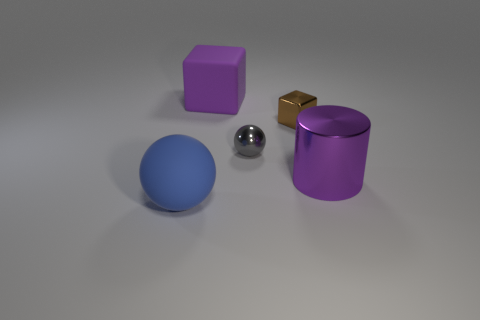What is the material of the purple thing in front of the large rubber object behind the tiny gray shiny thing?
Your answer should be very brief. Metal. Is there another thing of the same shape as the blue thing?
Keep it short and to the point. Yes. What color is the metallic thing that is the same size as the purple block?
Your answer should be very brief. Purple. How many objects are either things to the left of the big purple metal thing or objects that are to the left of the big matte cube?
Provide a succinct answer. 4. How many objects are either small gray metal things or large rubber things?
Offer a very short reply. 3. There is a thing that is both to the right of the big purple rubber object and on the left side of the brown shiny object; how big is it?
Ensure brevity in your answer.  Small. What number of large cubes have the same material as the blue ball?
Your response must be concise. 1. What is the color of the small block that is the same material as the big purple cylinder?
Your answer should be compact. Brown. Does the matte object that is behind the big blue object have the same color as the tiny block?
Offer a terse response. No. What is the large purple thing that is on the right side of the large purple cube made of?
Offer a very short reply. Metal. 